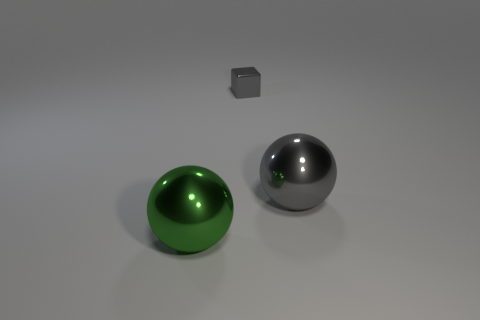How many large gray things have the same shape as the small thing?
Offer a terse response. 0. What is the big object that is to the right of the large thing in front of the metal ball that is on the right side of the big green metal thing made of?
Make the answer very short. Metal. There is a tiny shiny thing; are there any big metallic balls in front of it?
Ensure brevity in your answer.  Yes. What shape is the green shiny thing that is the same size as the gray metal sphere?
Your answer should be compact. Sphere. Do the block and the large green ball have the same material?
Provide a succinct answer. Yes. What number of rubber objects are either green things or tiny blue blocks?
Provide a succinct answer. 0. There is a big object that is the same color as the block; what shape is it?
Give a very brief answer. Sphere. There is a large thing on the right side of the big green shiny ball; does it have the same color as the small cube?
Provide a succinct answer. Yes. There is a large thing that is in front of the big object that is behind the green thing; what is its shape?
Offer a terse response. Sphere. What number of things are large shiny things on the right side of the big green ball or large spheres that are on the right side of the green ball?
Your response must be concise. 1. 